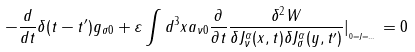Convert formula to latex. <formula><loc_0><loc_0><loc_500><loc_500>- \frac { d } { d t } \delta ( t - t ^ { \prime } ) g _ { \sigma 0 } + \varepsilon \int d ^ { 3 } x a _ { \nu 0 } \frac { \partial } { \partial t } \frac { \delta ^ { 2 } W } { \delta J _ { \nu } ^ { \alpha } ( x , t ) \delta J _ { \sigma } ^ { \alpha } ( y , t ^ { \prime } ) } | _ { _ { _ { 0 = J = \dots } } } = 0</formula> 